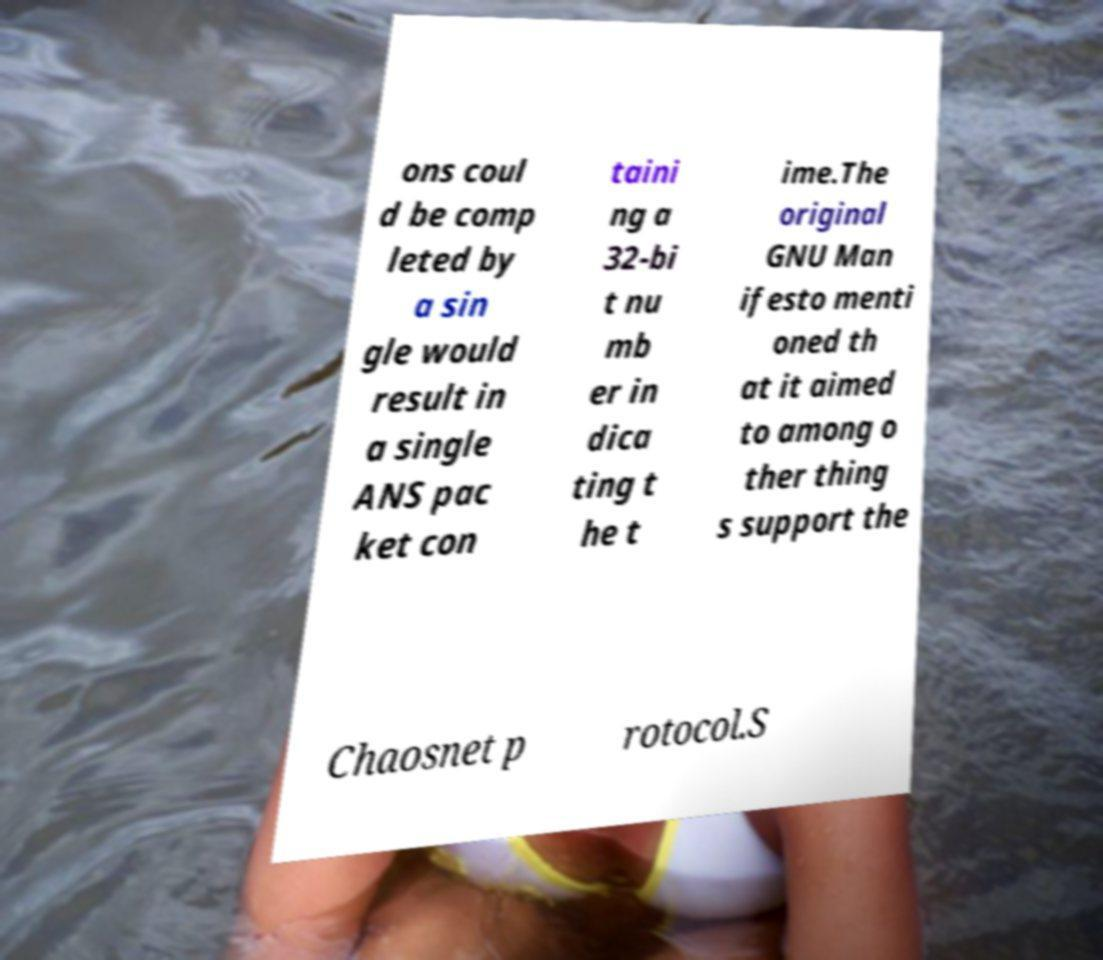Could you assist in decoding the text presented in this image and type it out clearly? ons coul d be comp leted by a sin gle would result in a single ANS pac ket con taini ng a 32-bi t nu mb er in dica ting t he t ime.The original GNU Man ifesto menti oned th at it aimed to among o ther thing s support the Chaosnet p rotocol.S 